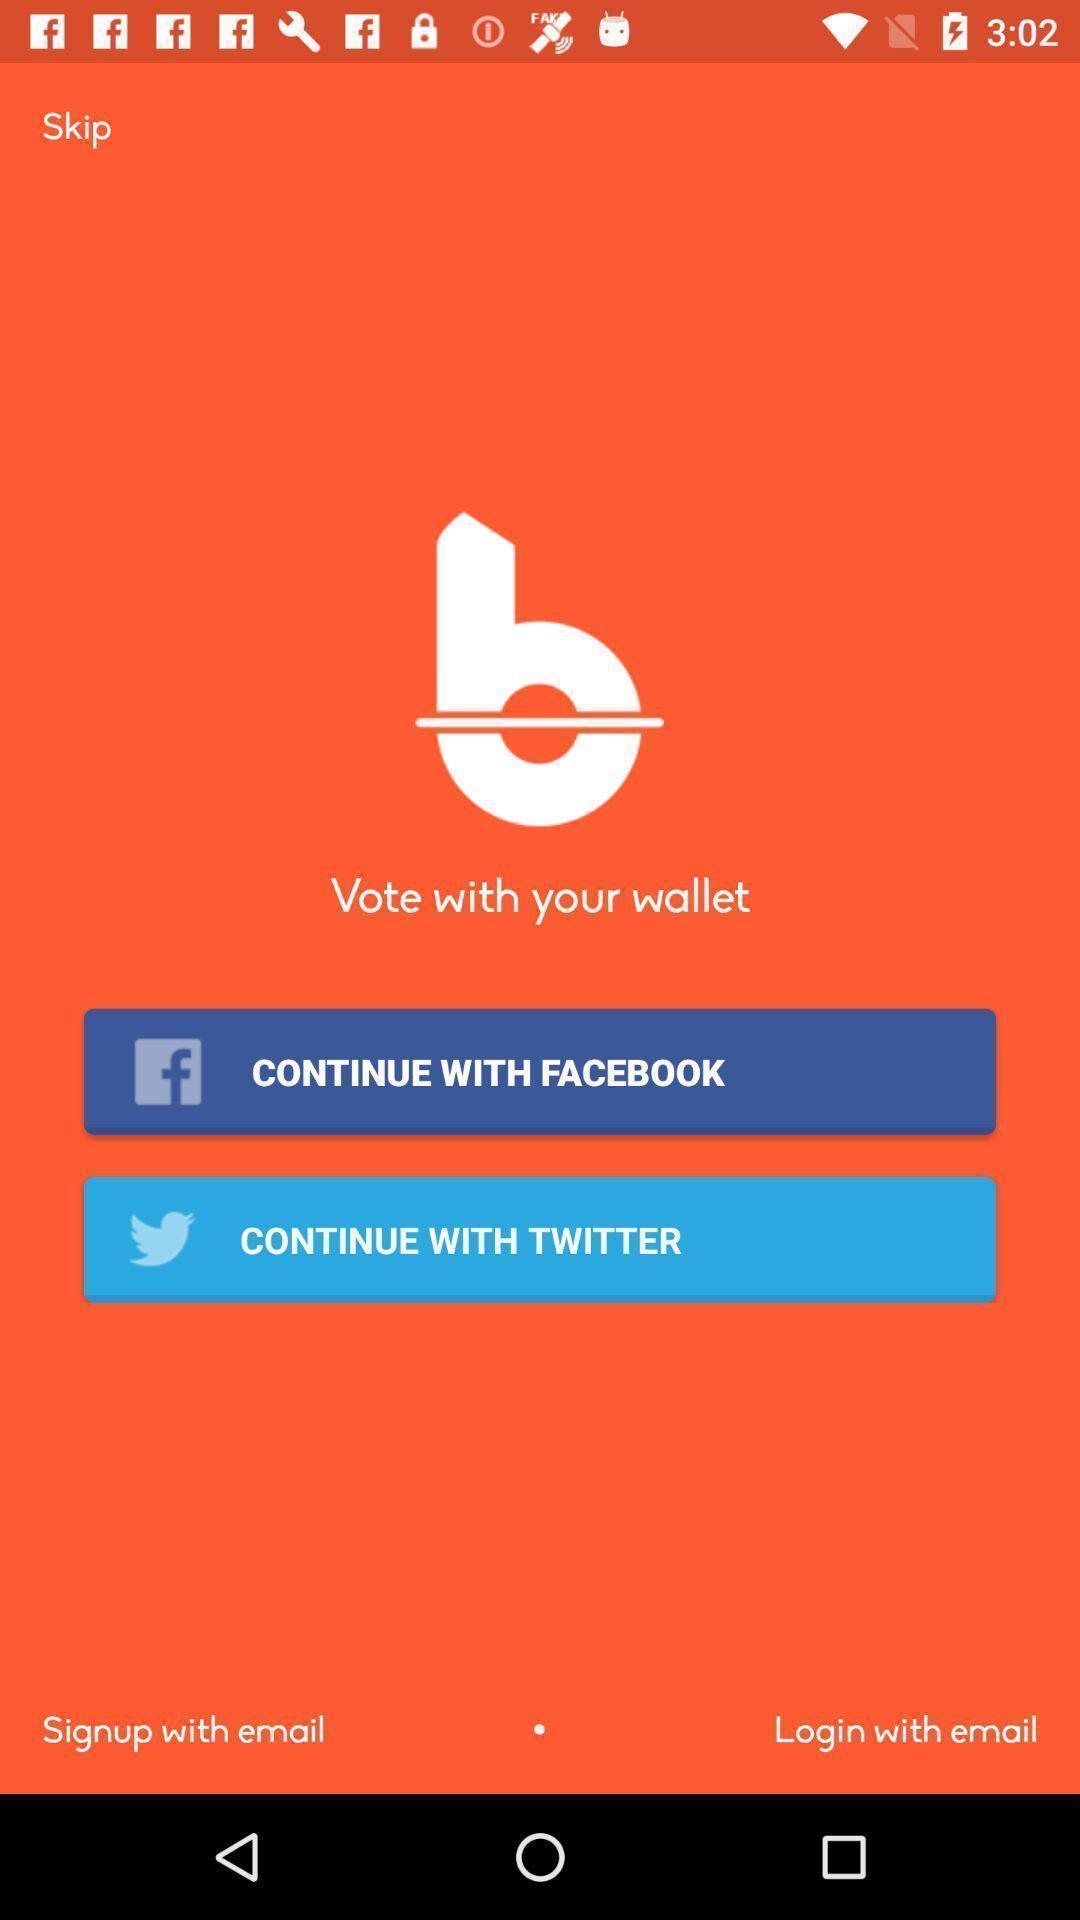Give me a narrative description of this picture. Page displaying signing in information about a barcode scanning application. 